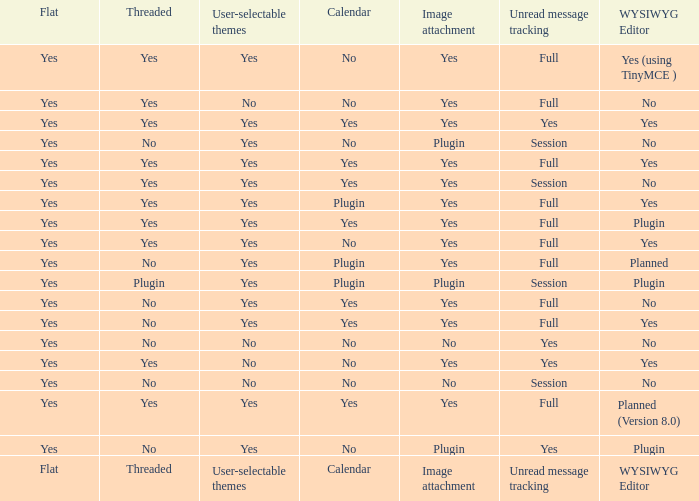Can you parse all the data within this table? {'header': ['Flat', 'Threaded', 'User-selectable themes', 'Calendar', 'Image attachment', 'Unread message tracking', 'WYSIWYG Editor'], 'rows': [['Yes', 'Yes', 'Yes', 'No', 'Yes', 'Full', 'Yes (using TinyMCE )'], ['Yes', 'Yes', 'No', 'No', 'Yes', 'Full', 'No'], ['Yes', 'Yes', 'Yes', 'Yes', 'Yes', 'Yes', 'Yes'], ['Yes', 'No', 'Yes', 'No', 'Plugin', 'Session', 'No'], ['Yes', 'Yes', 'Yes', 'Yes', 'Yes', 'Full', 'Yes'], ['Yes', 'Yes', 'Yes', 'Yes', 'Yes', 'Session', 'No'], ['Yes', 'Yes', 'Yes', 'Plugin', 'Yes', 'Full', 'Yes'], ['Yes', 'Yes', 'Yes', 'Yes', 'Yes', 'Full', 'Plugin'], ['Yes', 'Yes', 'Yes', 'No', 'Yes', 'Full', 'Yes'], ['Yes', 'No', 'Yes', 'Plugin', 'Yes', 'Full', 'Planned'], ['Yes', 'Plugin', 'Yes', 'Plugin', 'Plugin', 'Session', 'Plugin'], ['Yes', 'No', 'Yes', 'Yes', 'Yes', 'Full', 'No'], ['Yes', 'No', 'Yes', 'Yes', 'Yes', 'Full', 'Yes'], ['Yes', 'No', 'No', 'No', 'No', 'Yes', 'No'], ['Yes', 'Yes', 'No', 'No', 'Yes', 'Yes', 'Yes'], ['Yes', 'No', 'No', 'No', 'No', 'Session', 'No'], ['Yes', 'Yes', 'Yes', 'Yes', 'Yes', 'Full', 'Planned (Version 8.0)'], ['Yes', 'No', 'Yes', 'No', 'Plugin', 'Yes', 'Plugin'], ['Flat', 'Threaded', 'User-selectable themes', 'Calendar', 'Image attachment', 'Unread message tracking', 'WYSIWYG Editor']]} Which wysiwyg editor offers image attachment functionality along with a calendar plugin? Yes, Planned. 